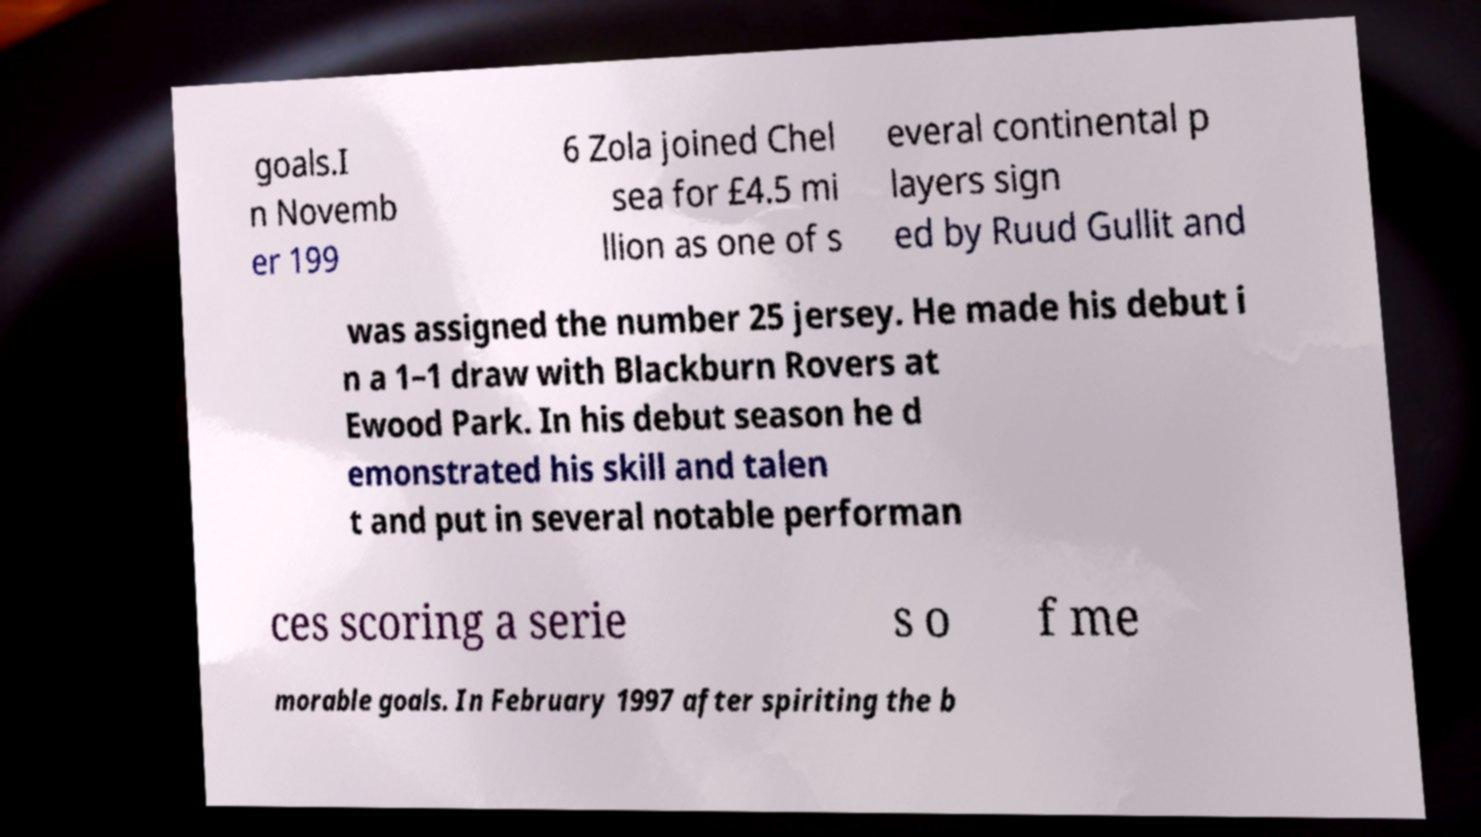There's text embedded in this image that I need extracted. Can you transcribe it verbatim? goals.I n Novemb er 199 6 Zola joined Chel sea for £4.5 mi llion as one of s everal continental p layers sign ed by Ruud Gullit and was assigned the number 25 jersey. He made his debut i n a 1–1 draw with Blackburn Rovers at Ewood Park. In his debut season he d emonstrated his skill and talen t and put in several notable performan ces scoring a serie s o f me morable goals. In February 1997 after spiriting the b 